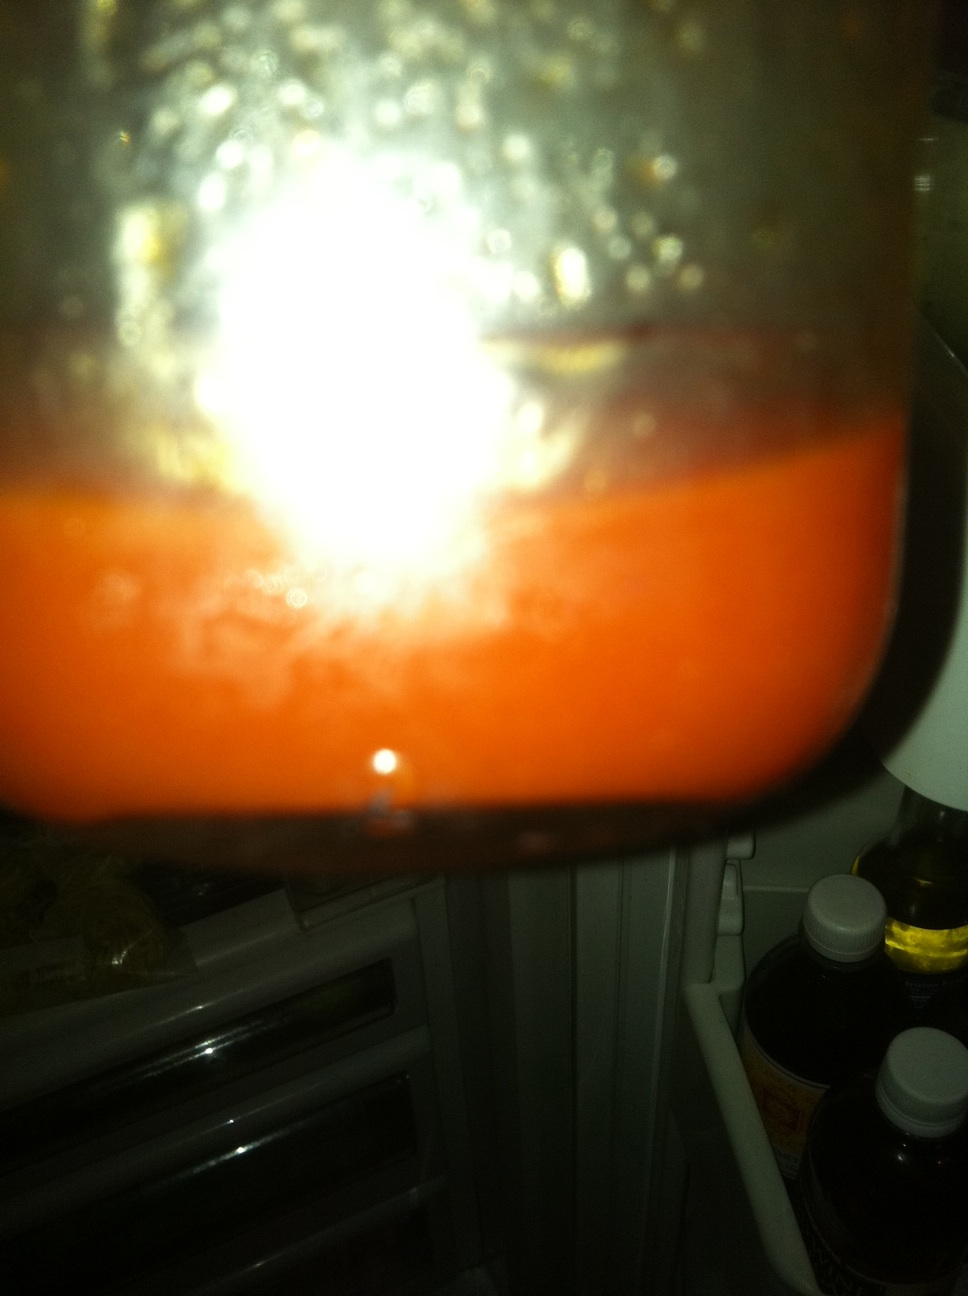What could be the main ingredients in this dressing based on its color? The reddish-orange color of the dressing suggests it might contain ingredients like tomatoes, red peppers, or perhaps ingredients that impart a similar hue such as paprika or chili powder. 